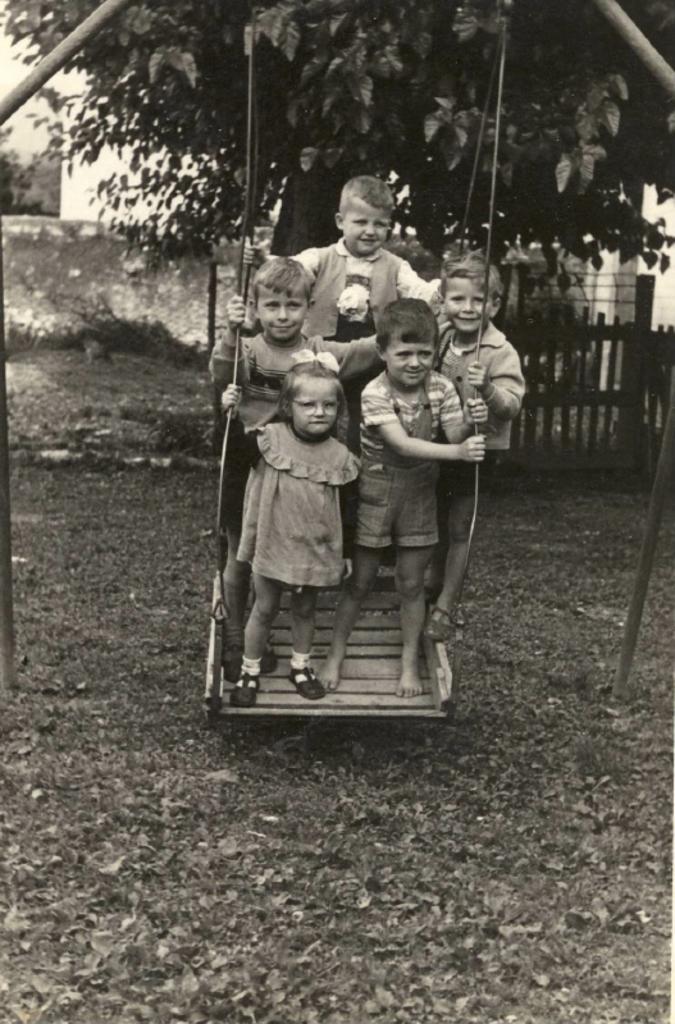Could you give a brief overview of what you see in this image? In this image there are group of persons standing and smiling. In the background there is a tree and there is a fence and there are plants. On the ground there are dry leaves. 